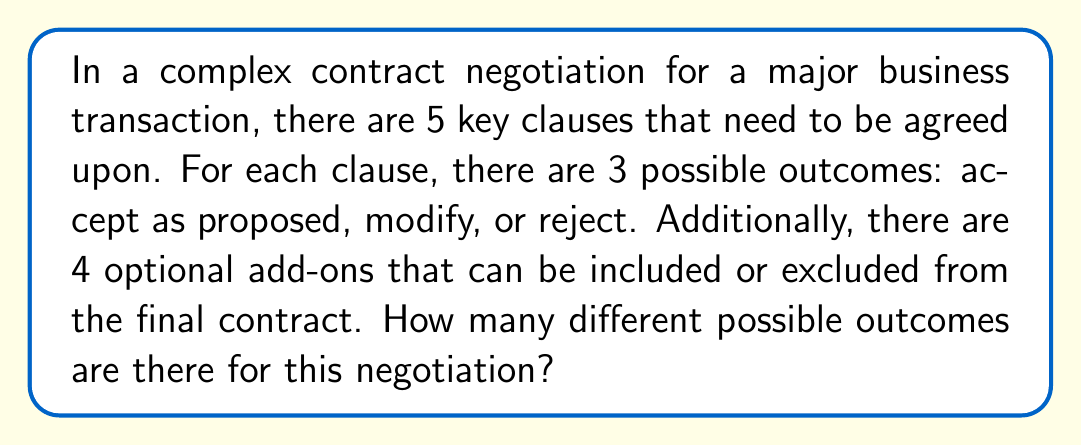Provide a solution to this math problem. To solve this problem, we need to apply the multiplication principle of counting. Let's break it down step by step:

1. For the key clauses:
   - There are 5 key clauses, each with 3 possible outcomes.
   - The number of possibilities for the key clauses is $3^5$.

2. For the optional add-ons:
   - There are 4 optional add-ons, each of which can be included or excluded.
   - This is equivalent to a binary choice (yes/no) for each add-on.
   - The number of possibilities for the add-ons is $2^4$.

3. Combining the key clauses and add-ons:
   - According to the multiplication principle, we multiply the number of possibilities for each independent decision.
   - Total number of outcomes = (Outcomes for key clauses) × (Outcomes for add-ons)
   - Total number of outcomes = $3^5 \times 2^4$

4. Calculating the result:
   $$3^5 \times 2^4 = 243 \times 16 = 3,888$$

Therefore, there are 3,888 different possible outcomes for this negotiation.
Answer: $3,888$ 